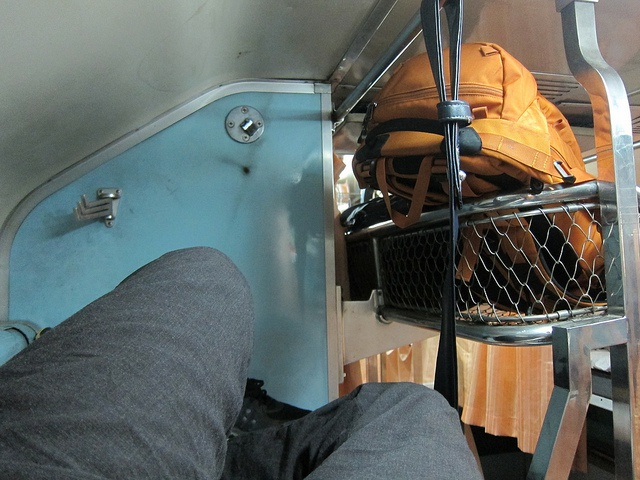Describe the objects in this image and their specific colors. I can see people in darkgray, gray, black, and purple tones and backpack in darkgray, black, orange, maroon, and brown tones in this image. 